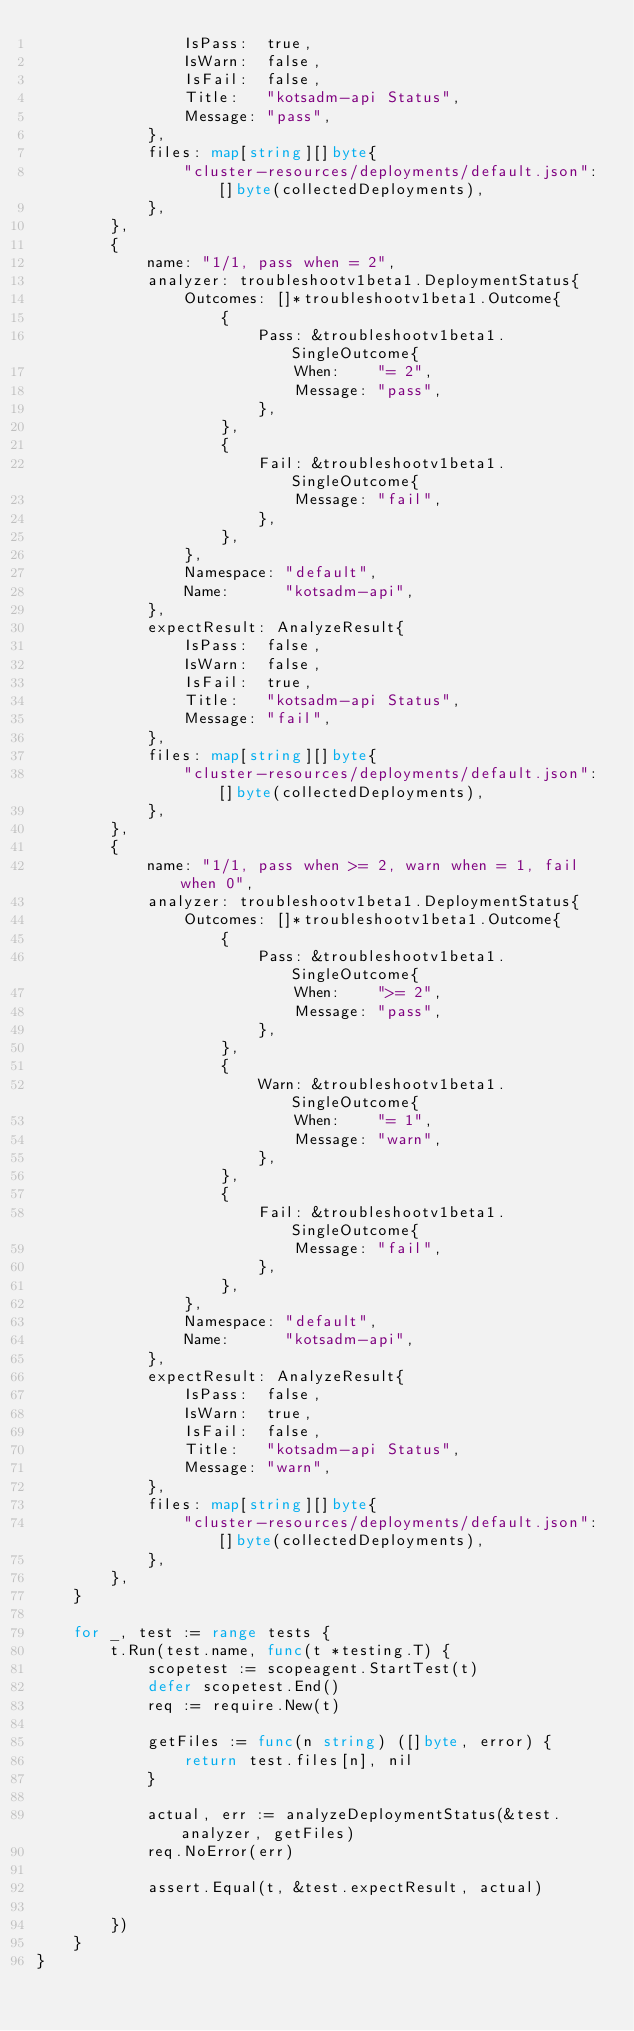Convert code to text. <code><loc_0><loc_0><loc_500><loc_500><_Go_>				IsPass:  true,
				IsWarn:  false,
				IsFail:  false,
				Title:   "kotsadm-api Status",
				Message: "pass",
			},
			files: map[string][]byte{
				"cluster-resources/deployments/default.json": []byte(collectedDeployments),
			},
		},
		{
			name: "1/1, pass when = 2",
			analyzer: troubleshootv1beta1.DeploymentStatus{
				Outcomes: []*troubleshootv1beta1.Outcome{
					{
						Pass: &troubleshootv1beta1.SingleOutcome{
							When:    "= 2",
							Message: "pass",
						},
					},
					{
						Fail: &troubleshootv1beta1.SingleOutcome{
							Message: "fail",
						},
					},
				},
				Namespace: "default",
				Name:      "kotsadm-api",
			},
			expectResult: AnalyzeResult{
				IsPass:  false,
				IsWarn:  false,
				IsFail:  true,
				Title:   "kotsadm-api Status",
				Message: "fail",
			},
			files: map[string][]byte{
				"cluster-resources/deployments/default.json": []byte(collectedDeployments),
			},
		},
		{
			name: "1/1, pass when >= 2, warn when = 1, fail when 0",
			analyzer: troubleshootv1beta1.DeploymentStatus{
				Outcomes: []*troubleshootv1beta1.Outcome{
					{
						Pass: &troubleshootv1beta1.SingleOutcome{
							When:    ">= 2",
							Message: "pass",
						},
					},
					{
						Warn: &troubleshootv1beta1.SingleOutcome{
							When:    "= 1",
							Message: "warn",
						},
					},
					{
						Fail: &troubleshootv1beta1.SingleOutcome{
							Message: "fail",
						},
					},
				},
				Namespace: "default",
				Name:      "kotsadm-api",
			},
			expectResult: AnalyzeResult{
				IsPass:  false,
				IsWarn:  true,
				IsFail:  false,
				Title:   "kotsadm-api Status",
				Message: "warn",
			},
			files: map[string][]byte{
				"cluster-resources/deployments/default.json": []byte(collectedDeployments),
			},
		},
	}

	for _, test := range tests {
		t.Run(test.name, func(t *testing.T) {
			scopetest := scopeagent.StartTest(t)
			defer scopetest.End()
			req := require.New(t)

			getFiles := func(n string) ([]byte, error) {
				return test.files[n], nil
			}

			actual, err := analyzeDeploymentStatus(&test.analyzer, getFiles)
			req.NoError(err)

			assert.Equal(t, &test.expectResult, actual)

		})
	}
}
</code> 